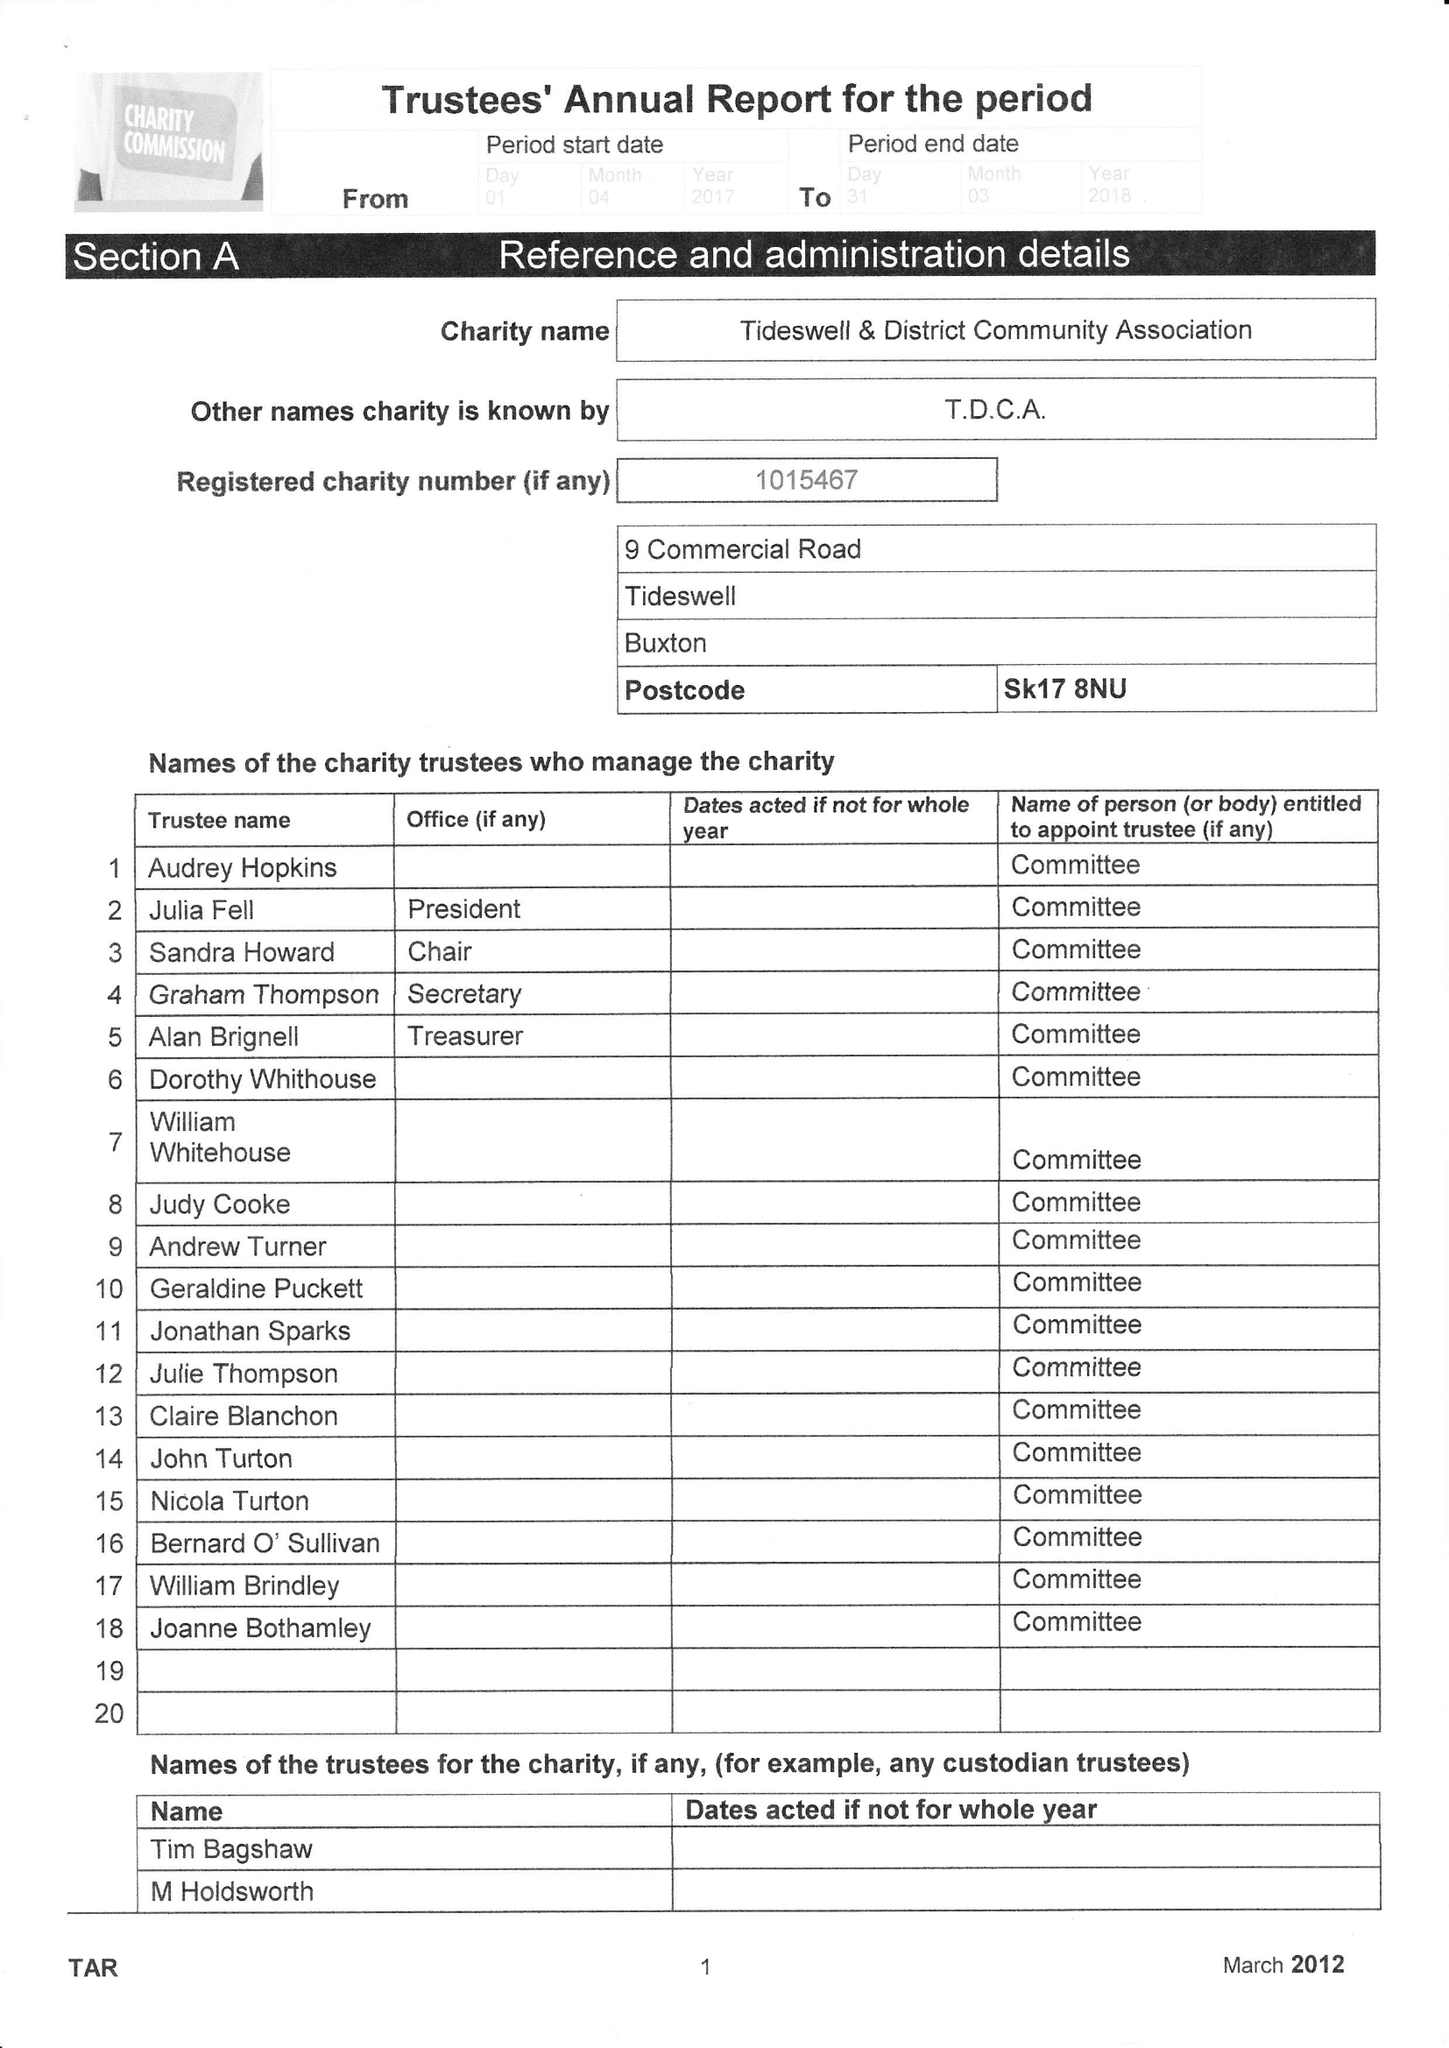What is the value for the address__street_line?
Answer the question using a single word or phrase. 9 COMMERCIAL ROAD 